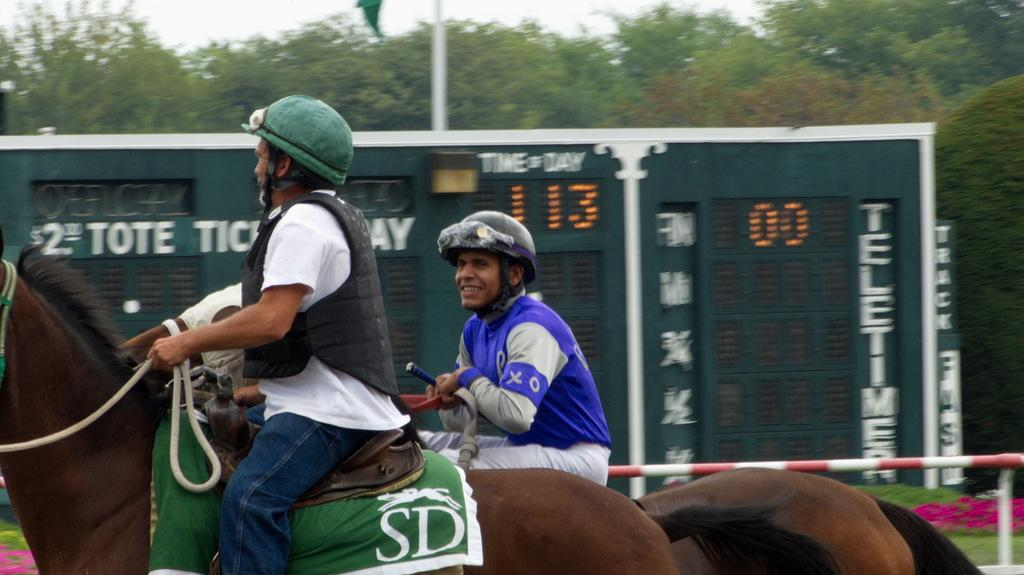How many people are in the image? There are two people in the image. What are the people doing in the image? The people are riding horses. What can be seen in the background of the image? There is a scoreboard, trees, and the sky visible in the background of the image. What type of steam is visible in the image? There is no steam present in the image; it features two people riding horses with a scoreboard, trees, and sky in the background. 